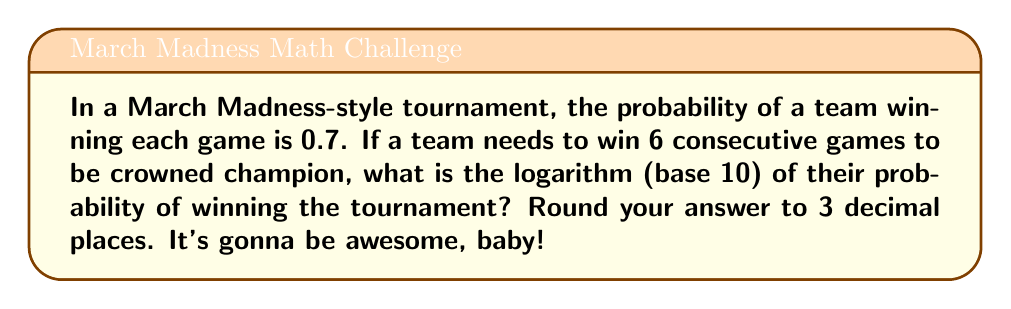Help me with this question. Let's break this down step-by-step, just like Dick Vitale analyzing a game:

1) The probability of winning one game is 0.7.

2) To win the tournament, the team needs to win 6 consecutive games. This means we need to calculate $(0.7)^6$.

3) We can use the logarithm property that states: $\log_a(x^n) = n\log_a(x)$

4) In this case, we want $\log_{10}((0.7)^6)$

5) Using the property mentioned in step 3:
   $\log_{10}((0.7)^6) = 6\log_{10}(0.7)$

6) Now we need to calculate $\log_{10}(0.7)$:
   $\log_{10}(0.7) \approx -0.15490196$

7) Multiplying by 6:
   $6 \times (-0.15490196) \approx -0.92941176$

8) Rounding to 3 decimal places:
   $-0.929$

This negative logarithm indicates that the probability is less than 1, which makes sense for an unlikely event like winning 6 games in a row.
Answer: $-0.929$ 